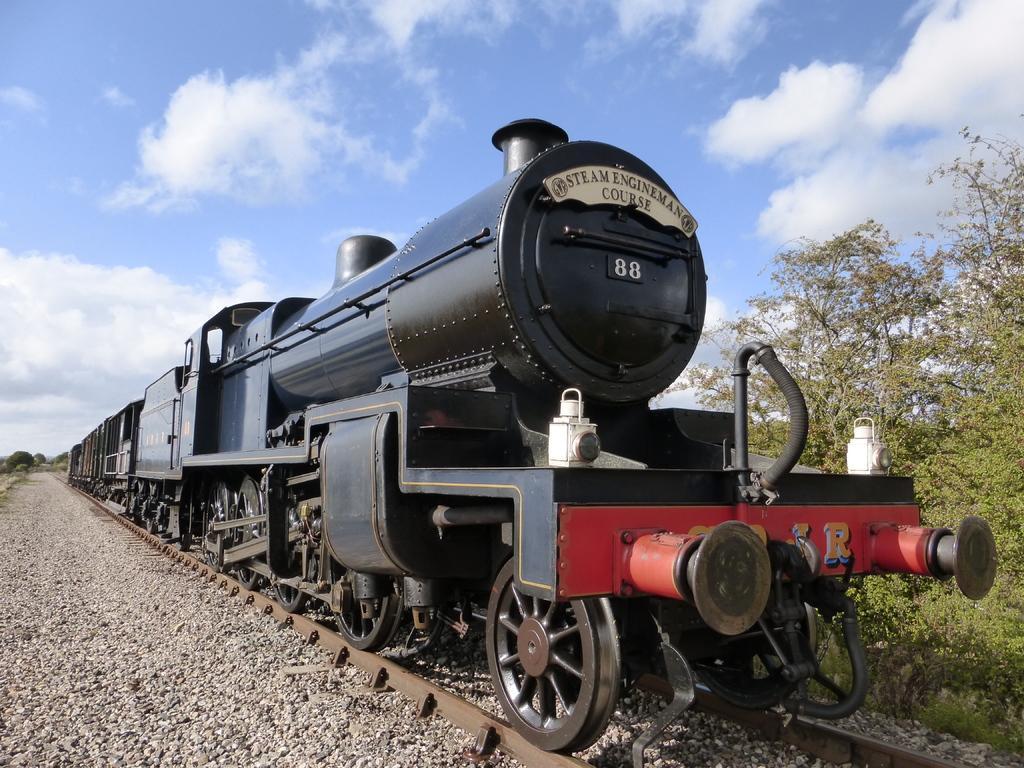How would you summarize this image in a sentence or two? In this picture there is a black color train on the track and there are trees in the right corner and there are small rocks in the left corner and there are trees in the background and the sky is a bit cloudy. 